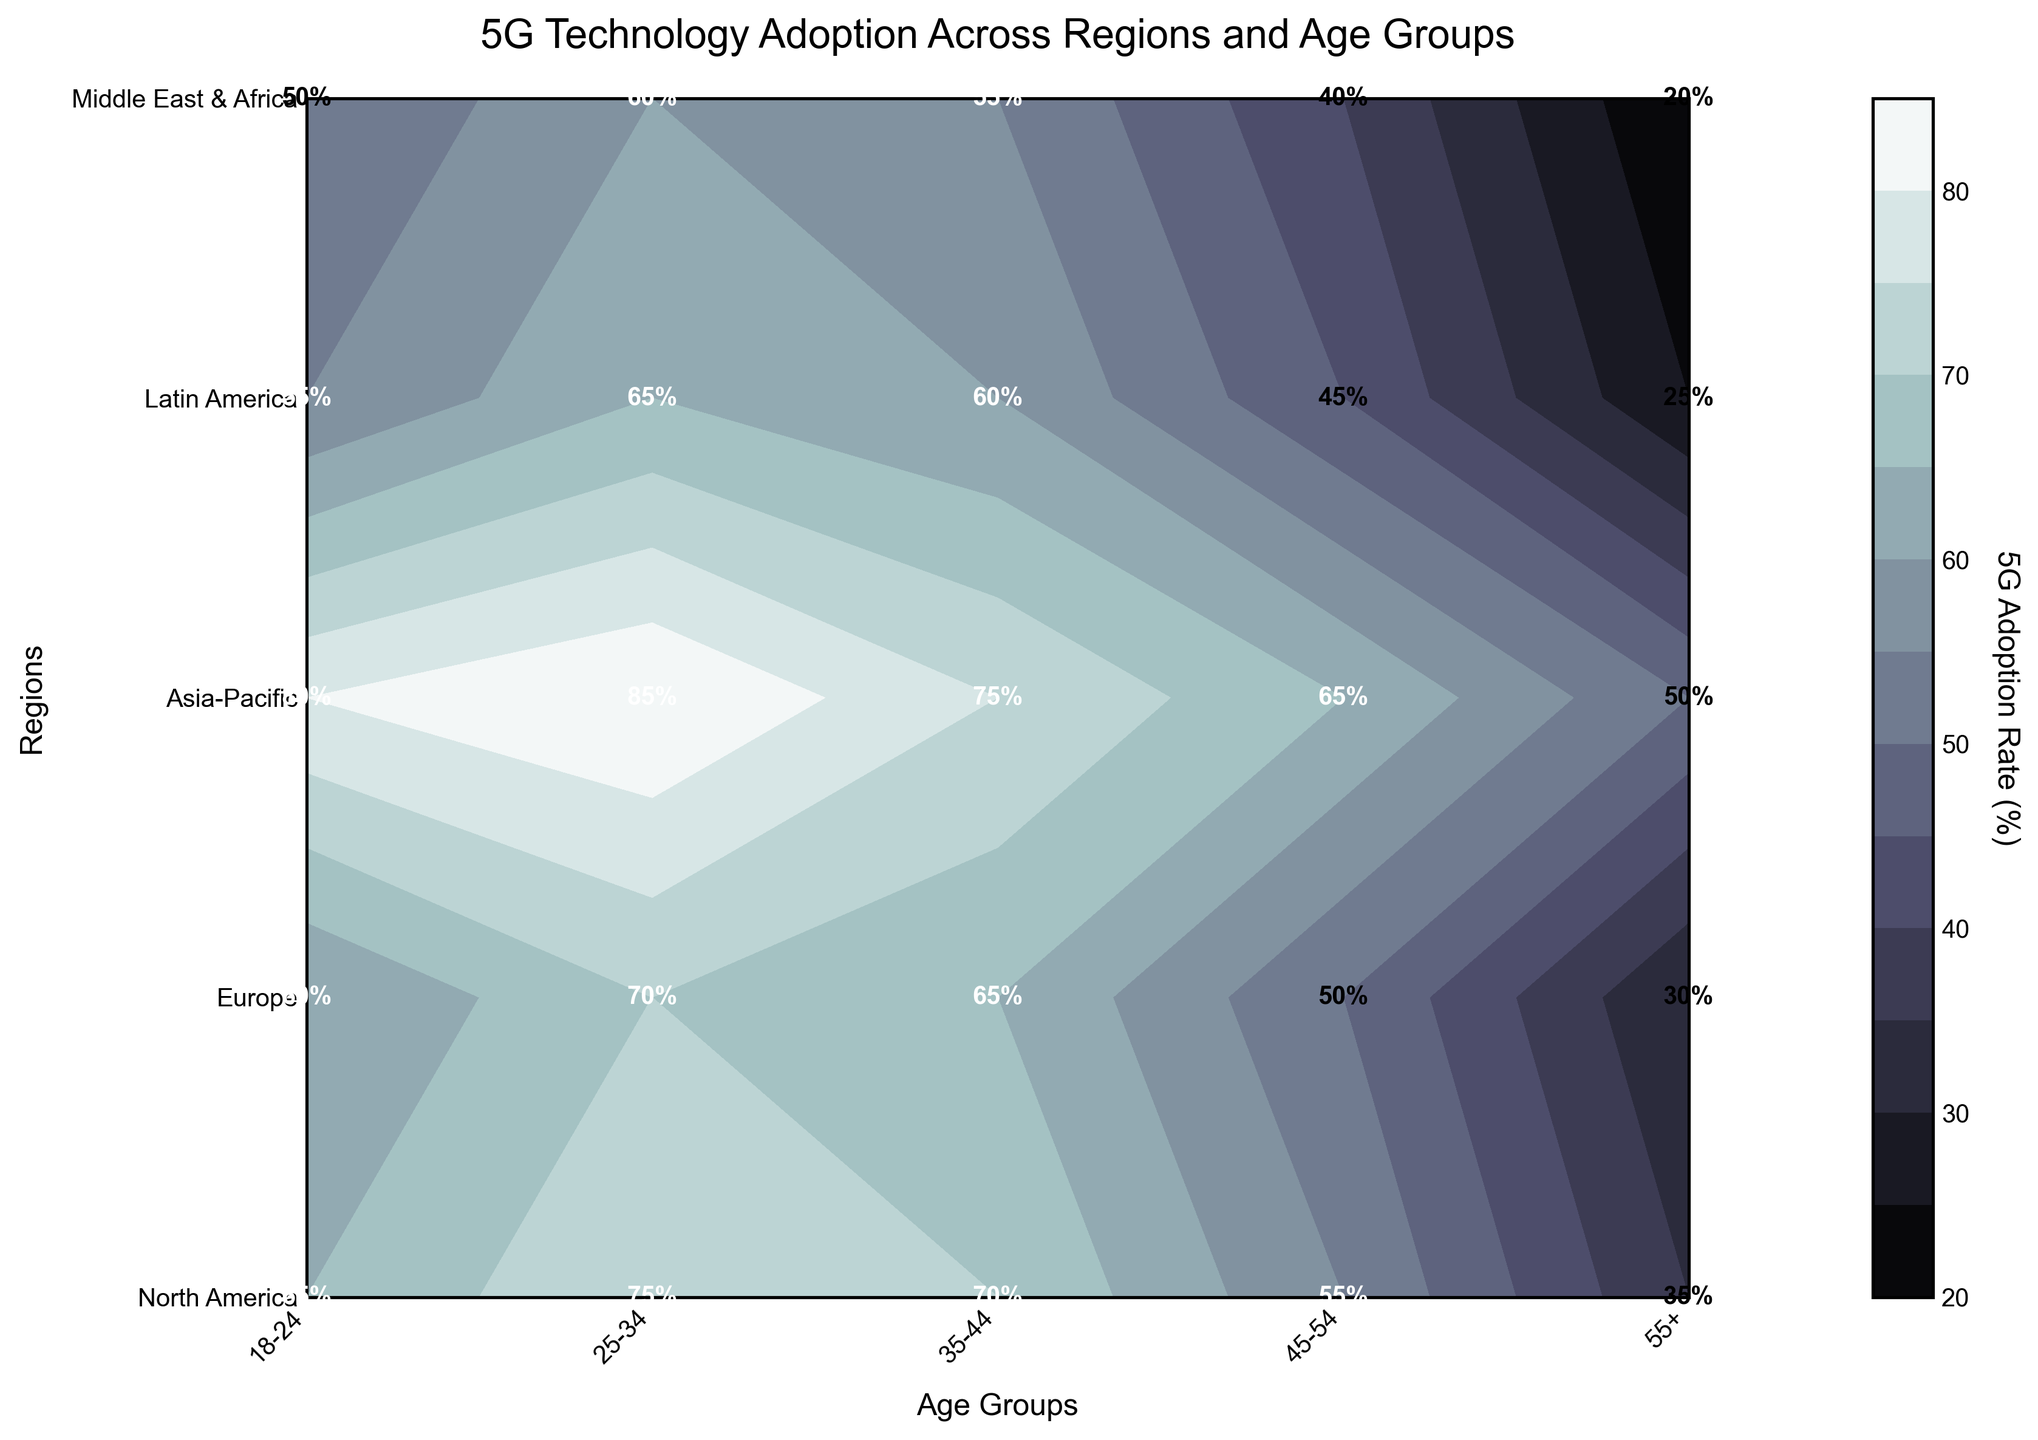What is the title of the figure? The title of the figure is located at the top. It typically provides a summary of what the figure represents.
Answer: 5G Technology Adoption Across Regions and Age Groups Which age group in North America has the highest 5G adoption rate? Look at the numerical labels within the contours for North America rows and find the highest value.
Answer: 25-34 What is the 5G adoption rate for the 55+ age group in Europe? Find the intersection of the row labeled 'Europe' and the column labeled '55+'. The number at this intersection represents the 5G adoption rate for that age group in that region.
Answer: 30 Which region shows the largest discrepancy in 5G adoption rates across different age groups? Compare the numerical labels and observe the differences between the highest and lowest values for each region. The region with the largest difference has the largest discrepancy.
Answer: North America (75 - 35 = 40) How does the 5G adoption rate for the 35-44 age group compare between Asia-Pacific and Latin America? Find and compare the numbers in the columns labeled '35-44' for both 'Asia-Pacific' and 'Latin America'.
Answer: Higher in Asia-Pacific (75 vs. 60) What is the average 5G adoption rate for all age groups in the Middle East & Africa? Sum all 5G adoption rates for the Middle East & Africa and divide by the number of age groups. (50+60+55+40+20) / 5 = 45
Answer: 45 Which age group generally has the lowest 5G adoption rate across all regions? Compare the 5G adoption rates for each age group across all regions and determine which age group has the lowest values on average.
Answer: 55+ In which region does the 18-24 age group have a higher 5G adoption rate compared to the 45-54 age group? Compare the 5G adoption rates between the 18-24 and 45-54 age groups for each region. Find the regions where the rate of the 18-24 group is higher.
Answer: All regions What is the second highest 5G adoption rate observed in the figure? Identify all numerical labels and pick the second highest value.
Answer: 85 What is the contour color representing the highest level of 5G adoption rate and in which region/age group does it occur? The highest level of 5G adoption rate is represented by the darkest contour shade on the plot. Identify the darkest shade and locate the corresponding region and age group.
Answer: Asia-Pacific, 25-34 